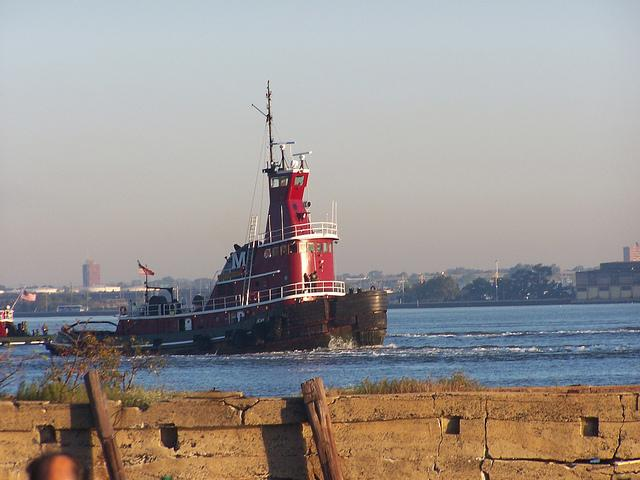The boat here moves under what sort of power? Please explain your reasoning. engine. The boat on the water has an engine that helps it move on the water. 